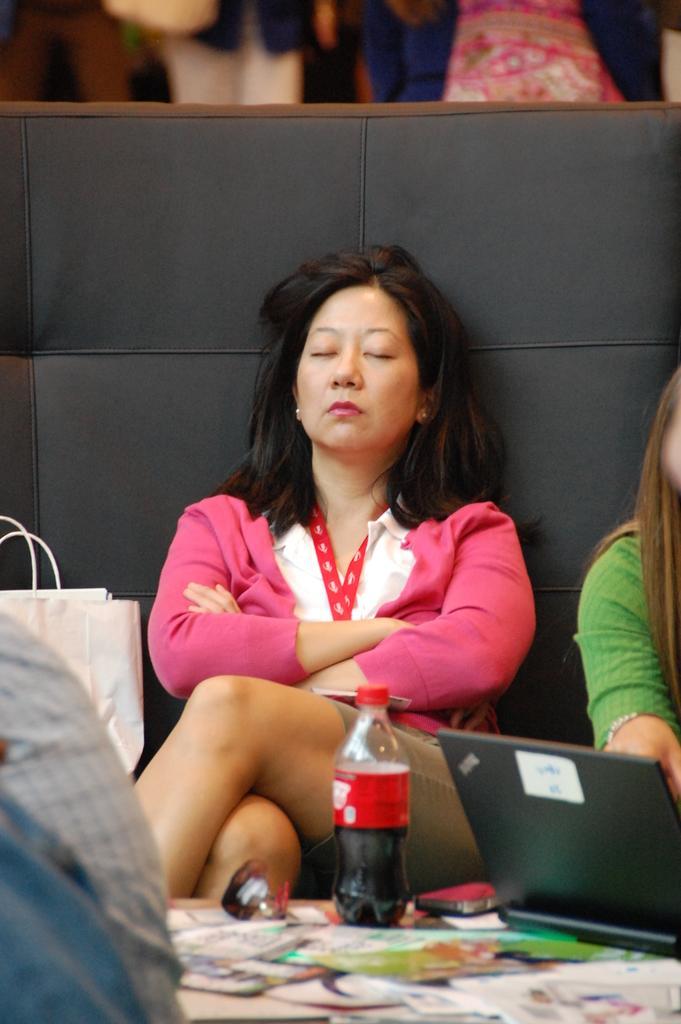How would you summarize this image in a sentence or two? Bottom of the image there is a table, on the table there is a bottle and laptop and there are some papers. In the middle of the image two persons sitting on a couch and there is a white color bag. 